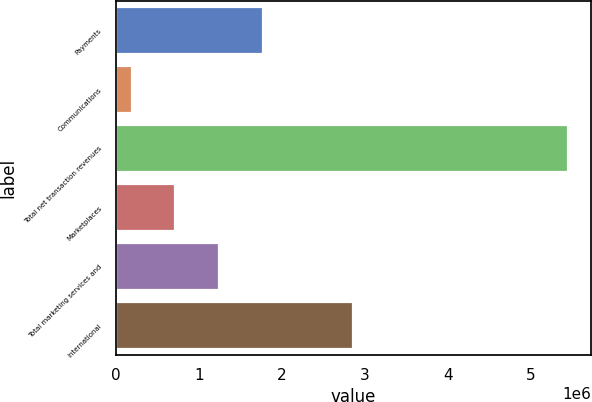Convert chart. <chart><loc_0><loc_0><loc_500><loc_500><bar_chart><fcel>Payments<fcel>Communications<fcel>Total net transaction revenues<fcel>Marketplaces<fcel>Total marketing services and<fcel>International<nl><fcel>1.76901e+06<fcel>189110<fcel>5.45544e+06<fcel>715743<fcel>1.24238e+06<fcel>2.86076e+06<nl></chart> 